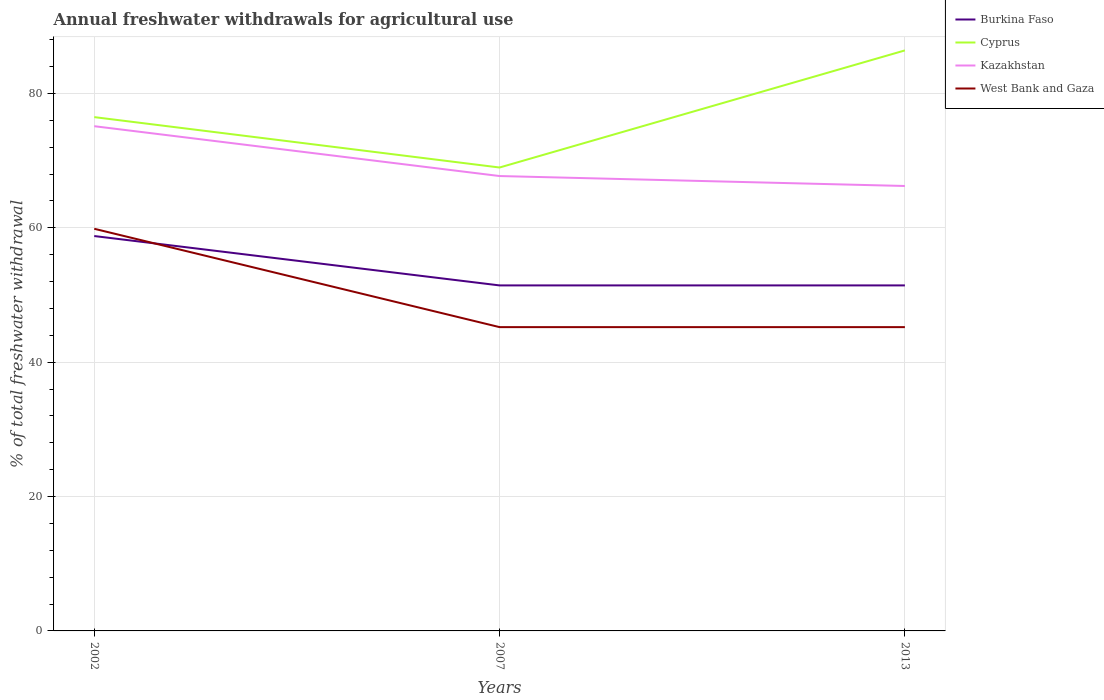How many different coloured lines are there?
Offer a very short reply. 4. Is the number of lines equal to the number of legend labels?
Provide a succinct answer. Yes. Across all years, what is the maximum total annual withdrawals from freshwater in Cyprus?
Keep it short and to the point. 68.98. In which year was the total annual withdrawals from freshwater in Kazakhstan maximum?
Provide a short and direct response. 2013. What is the total total annual withdrawals from freshwater in West Bank and Gaza in the graph?
Provide a succinct answer. 0. What is the difference between the highest and the second highest total annual withdrawals from freshwater in Burkina Faso?
Ensure brevity in your answer.  7.35. What is the difference between the highest and the lowest total annual withdrawals from freshwater in West Bank and Gaza?
Offer a very short reply. 1. Is the total annual withdrawals from freshwater in Kazakhstan strictly greater than the total annual withdrawals from freshwater in Burkina Faso over the years?
Ensure brevity in your answer.  No. How many lines are there?
Keep it short and to the point. 4. How many years are there in the graph?
Ensure brevity in your answer.  3. Are the values on the major ticks of Y-axis written in scientific E-notation?
Your answer should be very brief. No. Does the graph contain any zero values?
Provide a short and direct response. No. Where does the legend appear in the graph?
Your answer should be very brief. Top right. How many legend labels are there?
Provide a short and direct response. 4. What is the title of the graph?
Offer a very short reply. Annual freshwater withdrawals for agricultural use. Does "Seychelles" appear as one of the legend labels in the graph?
Keep it short and to the point. No. What is the label or title of the Y-axis?
Offer a very short reply. % of total freshwater withdrawal. What is the % of total freshwater withdrawal of Burkina Faso in 2002?
Your answer should be compact. 58.78. What is the % of total freshwater withdrawal in Cyprus in 2002?
Provide a succinct answer. 76.48. What is the % of total freshwater withdrawal of Kazakhstan in 2002?
Offer a terse response. 75.13. What is the % of total freshwater withdrawal of West Bank and Gaza in 2002?
Your answer should be very brief. 59.86. What is the % of total freshwater withdrawal in Burkina Faso in 2007?
Keep it short and to the point. 51.43. What is the % of total freshwater withdrawal in Cyprus in 2007?
Keep it short and to the point. 68.98. What is the % of total freshwater withdrawal in Kazakhstan in 2007?
Provide a succinct answer. 67.71. What is the % of total freshwater withdrawal in West Bank and Gaza in 2007?
Offer a terse response. 45.22. What is the % of total freshwater withdrawal of Burkina Faso in 2013?
Provide a short and direct response. 51.43. What is the % of total freshwater withdrawal of Cyprus in 2013?
Offer a terse response. 86.41. What is the % of total freshwater withdrawal in Kazakhstan in 2013?
Your response must be concise. 66.23. What is the % of total freshwater withdrawal of West Bank and Gaza in 2013?
Provide a short and direct response. 45.22. Across all years, what is the maximum % of total freshwater withdrawal in Burkina Faso?
Your response must be concise. 58.78. Across all years, what is the maximum % of total freshwater withdrawal of Cyprus?
Your response must be concise. 86.41. Across all years, what is the maximum % of total freshwater withdrawal in Kazakhstan?
Ensure brevity in your answer.  75.13. Across all years, what is the maximum % of total freshwater withdrawal in West Bank and Gaza?
Ensure brevity in your answer.  59.86. Across all years, what is the minimum % of total freshwater withdrawal of Burkina Faso?
Offer a terse response. 51.43. Across all years, what is the minimum % of total freshwater withdrawal in Cyprus?
Provide a succinct answer. 68.98. Across all years, what is the minimum % of total freshwater withdrawal in Kazakhstan?
Give a very brief answer. 66.23. Across all years, what is the minimum % of total freshwater withdrawal in West Bank and Gaza?
Provide a short and direct response. 45.22. What is the total % of total freshwater withdrawal in Burkina Faso in the graph?
Make the answer very short. 161.64. What is the total % of total freshwater withdrawal in Cyprus in the graph?
Offer a very short reply. 231.87. What is the total % of total freshwater withdrawal of Kazakhstan in the graph?
Provide a short and direct response. 209.07. What is the total % of total freshwater withdrawal of West Bank and Gaza in the graph?
Offer a terse response. 150.3. What is the difference between the % of total freshwater withdrawal in Burkina Faso in 2002 and that in 2007?
Ensure brevity in your answer.  7.35. What is the difference between the % of total freshwater withdrawal of Kazakhstan in 2002 and that in 2007?
Offer a terse response. 7.42. What is the difference between the % of total freshwater withdrawal of West Bank and Gaza in 2002 and that in 2007?
Offer a very short reply. 14.64. What is the difference between the % of total freshwater withdrawal in Burkina Faso in 2002 and that in 2013?
Make the answer very short. 7.35. What is the difference between the % of total freshwater withdrawal of Cyprus in 2002 and that in 2013?
Offer a very short reply. -9.93. What is the difference between the % of total freshwater withdrawal of Kazakhstan in 2002 and that in 2013?
Ensure brevity in your answer.  8.9. What is the difference between the % of total freshwater withdrawal in West Bank and Gaza in 2002 and that in 2013?
Your answer should be very brief. 14.64. What is the difference between the % of total freshwater withdrawal in Cyprus in 2007 and that in 2013?
Ensure brevity in your answer.  -17.43. What is the difference between the % of total freshwater withdrawal of Kazakhstan in 2007 and that in 2013?
Give a very brief answer. 1.48. What is the difference between the % of total freshwater withdrawal in West Bank and Gaza in 2007 and that in 2013?
Your response must be concise. 0. What is the difference between the % of total freshwater withdrawal in Burkina Faso in 2002 and the % of total freshwater withdrawal in Cyprus in 2007?
Ensure brevity in your answer.  -10.2. What is the difference between the % of total freshwater withdrawal of Burkina Faso in 2002 and the % of total freshwater withdrawal of Kazakhstan in 2007?
Provide a succinct answer. -8.93. What is the difference between the % of total freshwater withdrawal of Burkina Faso in 2002 and the % of total freshwater withdrawal of West Bank and Gaza in 2007?
Give a very brief answer. 13.56. What is the difference between the % of total freshwater withdrawal of Cyprus in 2002 and the % of total freshwater withdrawal of Kazakhstan in 2007?
Your response must be concise. 8.77. What is the difference between the % of total freshwater withdrawal in Cyprus in 2002 and the % of total freshwater withdrawal in West Bank and Gaza in 2007?
Offer a terse response. 31.26. What is the difference between the % of total freshwater withdrawal in Kazakhstan in 2002 and the % of total freshwater withdrawal in West Bank and Gaza in 2007?
Offer a very short reply. 29.91. What is the difference between the % of total freshwater withdrawal in Burkina Faso in 2002 and the % of total freshwater withdrawal in Cyprus in 2013?
Keep it short and to the point. -27.63. What is the difference between the % of total freshwater withdrawal of Burkina Faso in 2002 and the % of total freshwater withdrawal of Kazakhstan in 2013?
Give a very brief answer. -7.45. What is the difference between the % of total freshwater withdrawal of Burkina Faso in 2002 and the % of total freshwater withdrawal of West Bank and Gaza in 2013?
Offer a very short reply. 13.56. What is the difference between the % of total freshwater withdrawal of Cyprus in 2002 and the % of total freshwater withdrawal of Kazakhstan in 2013?
Your answer should be compact. 10.25. What is the difference between the % of total freshwater withdrawal of Cyprus in 2002 and the % of total freshwater withdrawal of West Bank and Gaza in 2013?
Provide a succinct answer. 31.26. What is the difference between the % of total freshwater withdrawal in Kazakhstan in 2002 and the % of total freshwater withdrawal in West Bank and Gaza in 2013?
Your answer should be compact. 29.91. What is the difference between the % of total freshwater withdrawal of Burkina Faso in 2007 and the % of total freshwater withdrawal of Cyprus in 2013?
Offer a terse response. -34.98. What is the difference between the % of total freshwater withdrawal of Burkina Faso in 2007 and the % of total freshwater withdrawal of Kazakhstan in 2013?
Ensure brevity in your answer.  -14.8. What is the difference between the % of total freshwater withdrawal in Burkina Faso in 2007 and the % of total freshwater withdrawal in West Bank and Gaza in 2013?
Offer a terse response. 6.21. What is the difference between the % of total freshwater withdrawal in Cyprus in 2007 and the % of total freshwater withdrawal in Kazakhstan in 2013?
Your answer should be compact. 2.75. What is the difference between the % of total freshwater withdrawal in Cyprus in 2007 and the % of total freshwater withdrawal in West Bank and Gaza in 2013?
Give a very brief answer. 23.76. What is the difference between the % of total freshwater withdrawal in Kazakhstan in 2007 and the % of total freshwater withdrawal in West Bank and Gaza in 2013?
Your answer should be compact. 22.49. What is the average % of total freshwater withdrawal of Burkina Faso per year?
Offer a terse response. 53.88. What is the average % of total freshwater withdrawal in Cyprus per year?
Ensure brevity in your answer.  77.29. What is the average % of total freshwater withdrawal of Kazakhstan per year?
Your response must be concise. 69.69. What is the average % of total freshwater withdrawal of West Bank and Gaza per year?
Keep it short and to the point. 50.1. In the year 2002, what is the difference between the % of total freshwater withdrawal of Burkina Faso and % of total freshwater withdrawal of Cyprus?
Your response must be concise. -17.7. In the year 2002, what is the difference between the % of total freshwater withdrawal of Burkina Faso and % of total freshwater withdrawal of Kazakhstan?
Keep it short and to the point. -16.35. In the year 2002, what is the difference between the % of total freshwater withdrawal of Burkina Faso and % of total freshwater withdrawal of West Bank and Gaza?
Ensure brevity in your answer.  -1.08. In the year 2002, what is the difference between the % of total freshwater withdrawal of Cyprus and % of total freshwater withdrawal of Kazakhstan?
Your answer should be very brief. 1.35. In the year 2002, what is the difference between the % of total freshwater withdrawal in Cyprus and % of total freshwater withdrawal in West Bank and Gaza?
Provide a succinct answer. 16.62. In the year 2002, what is the difference between the % of total freshwater withdrawal of Kazakhstan and % of total freshwater withdrawal of West Bank and Gaza?
Your answer should be compact. 15.27. In the year 2007, what is the difference between the % of total freshwater withdrawal of Burkina Faso and % of total freshwater withdrawal of Cyprus?
Your answer should be very brief. -17.55. In the year 2007, what is the difference between the % of total freshwater withdrawal of Burkina Faso and % of total freshwater withdrawal of Kazakhstan?
Ensure brevity in your answer.  -16.28. In the year 2007, what is the difference between the % of total freshwater withdrawal in Burkina Faso and % of total freshwater withdrawal in West Bank and Gaza?
Provide a succinct answer. 6.21. In the year 2007, what is the difference between the % of total freshwater withdrawal in Cyprus and % of total freshwater withdrawal in Kazakhstan?
Your answer should be compact. 1.27. In the year 2007, what is the difference between the % of total freshwater withdrawal of Cyprus and % of total freshwater withdrawal of West Bank and Gaza?
Keep it short and to the point. 23.76. In the year 2007, what is the difference between the % of total freshwater withdrawal of Kazakhstan and % of total freshwater withdrawal of West Bank and Gaza?
Keep it short and to the point. 22.49. In the year 2013, what is the difference between the % of total freshwater withdrawal of Burkina Faso and % of total freshwater withdrawal of Cyprus?
Your response must be concise. -34.98. In the year 2013, what is the difference between the % of total freshwater withdrawal of Burkina Faso and % of total freshwater withdrawal of Kazakhstan?
Keep it short and to the point. -14.8. In the year 2013, what is the difference between the % of total freshwater withdrawal of Burkina Faso and % of total freshwater withdrawal of West Bank and Gaza?
Your response must be concise. 6.21. In the year 2013, what is the difference between the % of total freshwater withdrawal of Cyprus and % of total freshwater withdrawal of Kazakhstan?
Your answer should be compact. 20.18. In the year 2013, what is the difference between the % of total freshwater withdrawal in Cyprus and % of total freshwater withdrawal in West Bank and Gaza?
Your answer should be compact. 41.19. In the year 2013, what is the difference between the % of total freshwater withdrawal in Kazakhstan and % of total freshwater withdrawal in West Bank and Gaza?
Make the answer very short. 21.01. What is the ratio of the % of total freshwater withdrawal in Cyprus in 2002 to that in 2007?
Offer a terse response. 1.11. What is the ratio of the % of total freshwater withdrawal in Kazakhstan in 2002 to that in 2007?
Keep it short and to the point. 1.11. What is the ratio of the % of total freshwater withdrawal of West Bank and Gaza in 2002 to that in 2007?
Your response must be concise. 1.32. What is the ratio of the % of total freshwater withdrawal in Cyprus in 2002 to that in 2013?
Provide a succinct answer. 0.89. What is the ratio of the % of total freshwater withdrawal of Kazakhstan in 2002 to that in 2013?
Your response must be concise. 1.13. What is the ratio of the % of total freshwater withdrawal in West Bank and Gaza in 2002 to that in 2013?
Your answer should be compact. 1.32. What is the ratio of the % of total freshwater withdrawal in Cyprus in 2007 to that in 2013?
Offer a very short reply. 0.8. What is the ratio of the % of total freshwater withdrawal in Kazakhstan in 2007 to that in 2013?
Keep it short and to the point. 1.02. What is the ratio of the % of total freshwater withdrawal in West Bank and Gaza in 2007 to that in 2013?
Offer a very short reply. 1. What is the difference between the highest and the second highest % of total freshwater withdrawal of Burkina Faso?
Your answer should be compact. 7.35. What is the difference between the highest and the second highest % of total freshwater withdrawal of Cyprus?
Ensure brevity in your answer.  9.93. What is the difference between the highest and the second highest % of total freshwater withdrawal in Kazakhstan?
Your answer should be very brief. 7.42. What is the difference between the highest and the second highest % of total freshwater withdrawal in West Bank and Gaza?
Your answer should be compact. 14.64. What is the difference between the highest and the lowest % of total freshwater withdrawal of Burkina Faso?
Offer a very short reply. 7.35. What is the difference between the highest and the lowest % of total freshwater withdrawal in Cyprus?
Make the answer very short. 17.43. What is the difference between the highest and the lowest % of total freshwater withdrawal in Kazakhstan?
Offer a very short reply. 8.9. What is the difference between the highest and the lowest % of total freshwater withdrawal in West Bank and Gaza?
Make the answer very short. 14.64. 